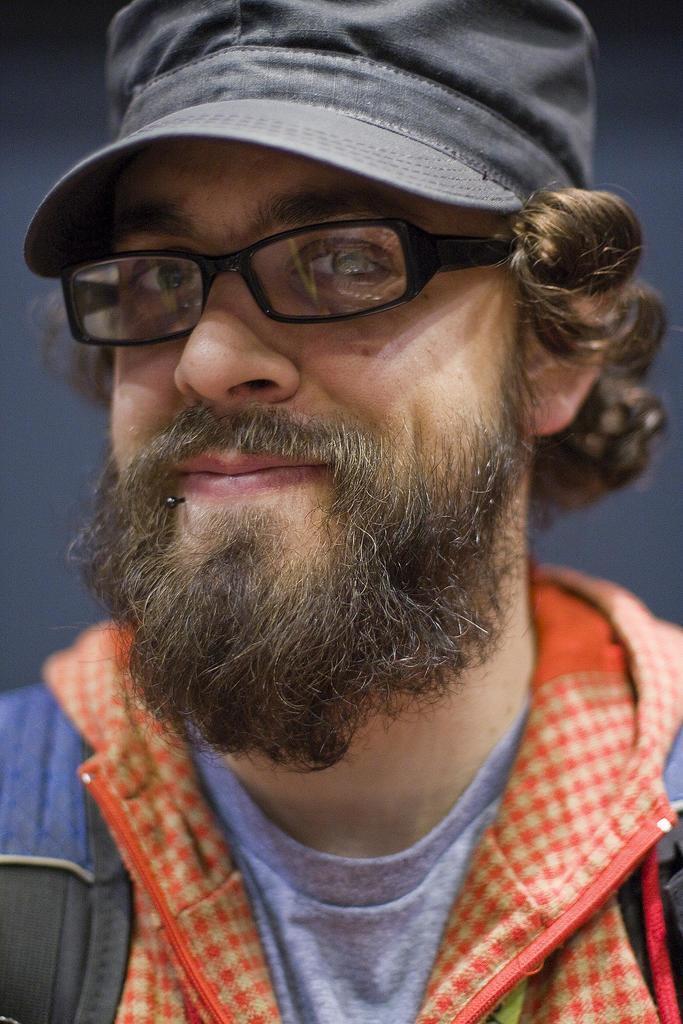In one or two sentences, can you explain what this image depicts? The man in front of the picture wearing a grey T-shirt, orange and black jacket is smiling. He is wearing the spectacles and a cap. I think he is posing for the photo. In the background, it is in blue color. 